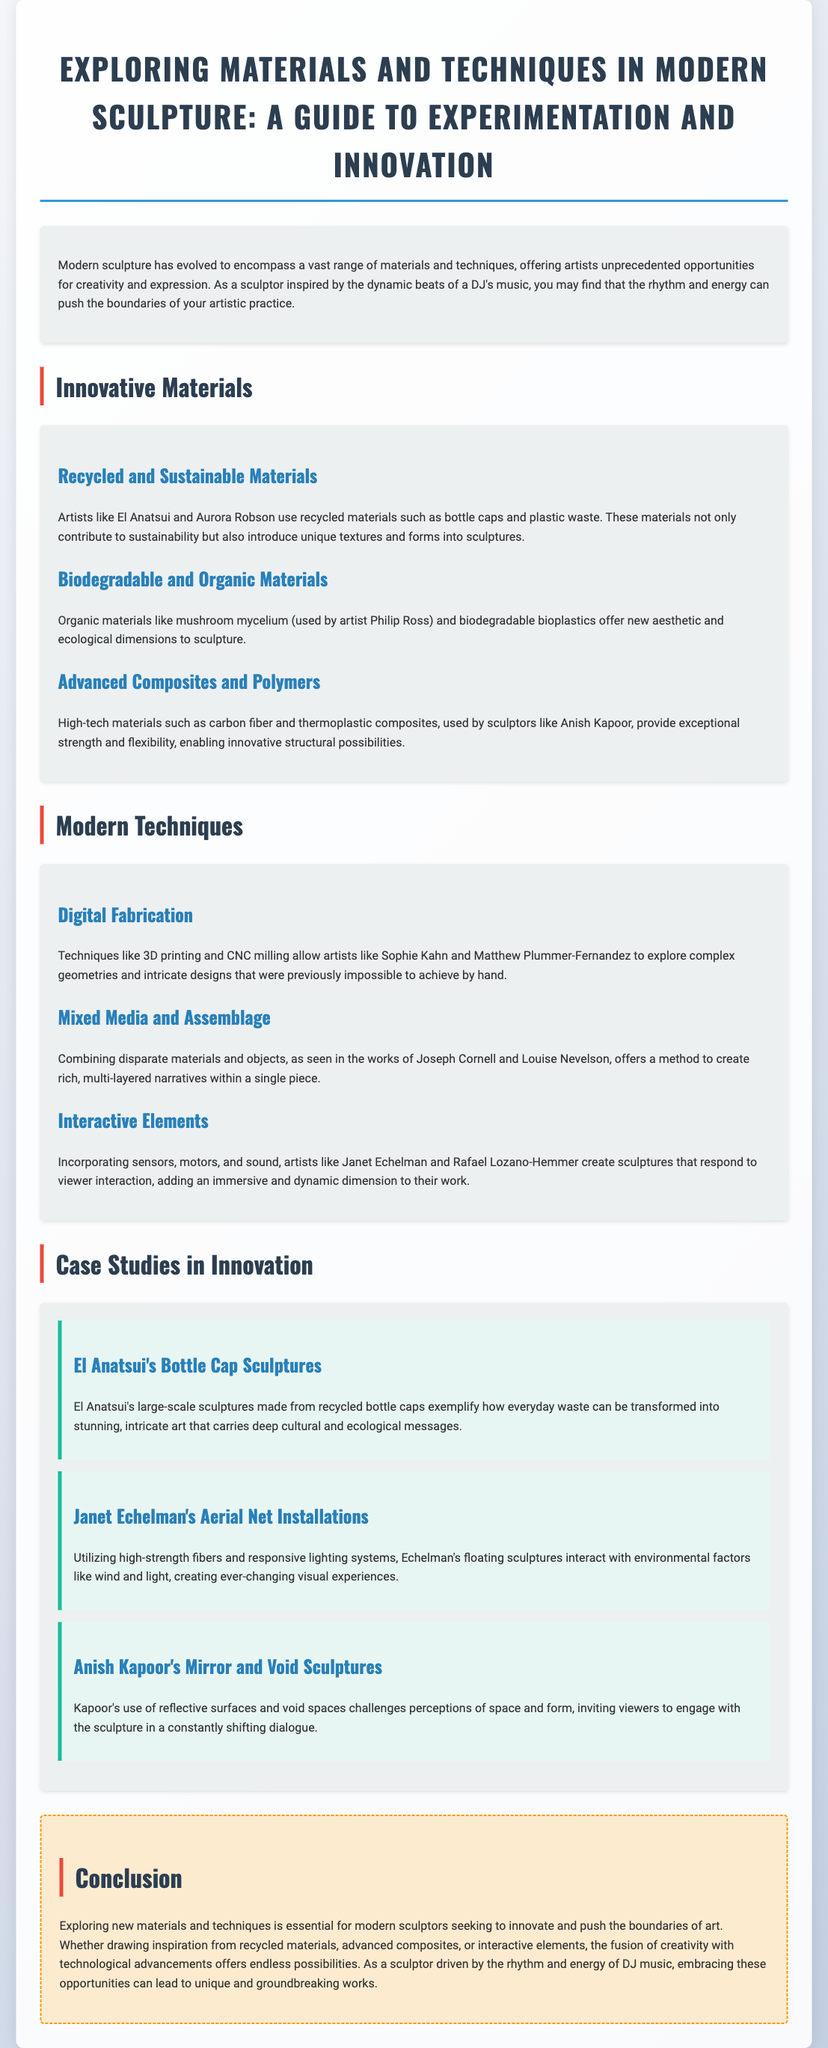What is the title of the document? The title of the document is clearly stated at the beginning, providing a focus on modern sculpture and innovation in materials and techniques.
Answer: Exploring Materials and Techniques in Modern Sculpture: A Guide to Experimentation and Innovation Who are some artists that use recycled materials? The document lists artists who utilize recycled materials, highlighting their contributions to sculpture and sustainability.
Answer: El Anatsui and Aurora Robson What type of materials does Philip Ross use? The text specifies the use of organic materials in sculpture, particularly those used by Philip Ross, indicating a new ecological dimension.
Answer: Mushroom mycelium What technique allows for complex geometries in sculptures? The document discusses modern techniques and identifies a specific method that enables intricate designs within sculpture.
Answer: Digital Fabrication Which artist is known for interactive sculpture? The document mentions artists who incorporate technology into their work, creating interactive experiences in art.
Answer: Janet Echelman What is a characteristic of El Anatsui's sculptures? The document describes the unique aspects of El Anatsui's work, focusing on the materials and cultural significance.
Answer: Recycled bottle caps What do advanced composites provide for sculptors? The document outlines the benefits of specific high-tech materials and how they enhance artistic possibilities.
Answer: Exceptional strength and flexibility What is a prominent feature of Anish Kapoor's sculptures? The text notes a unique aspect of Kapoor's work that engages viewers' perceptions of art, essential in his sculptural practice.
Answer: Reflective surfaces and void spaces What conclusion is drawn about experimentation in sculpture? The conclusion summarizes the importance of material and technique exploration in modern sculpture.
Answer: Essential for innovation 